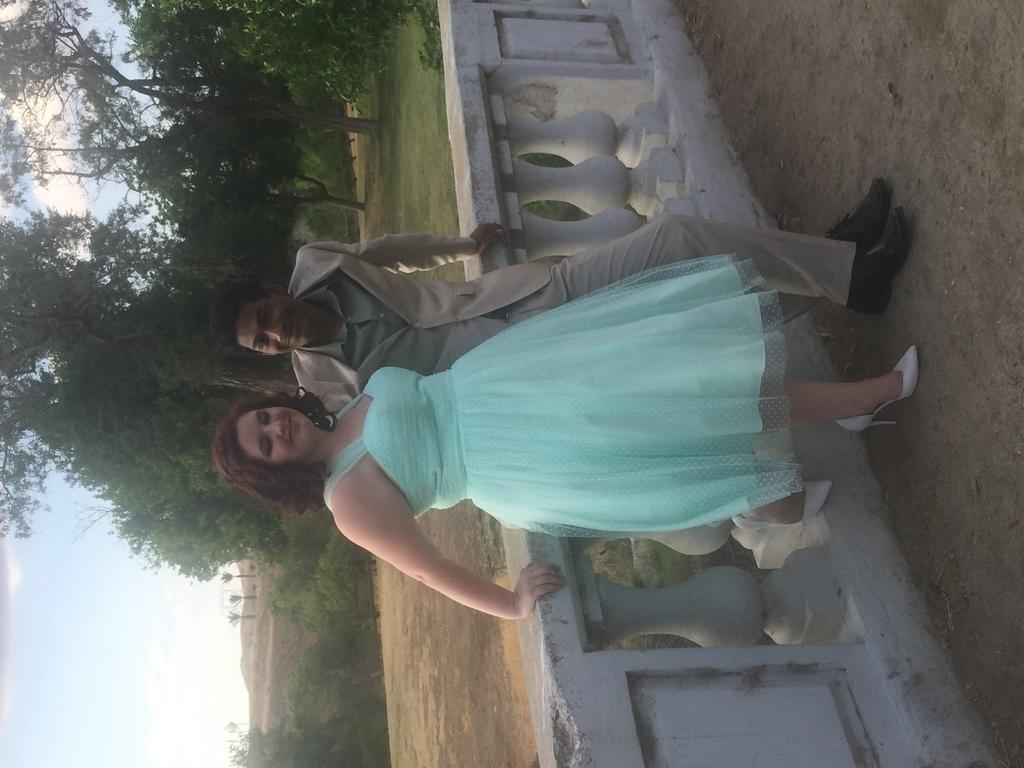How many people are present in the image? There are two people in the image. What is the primary surface visible in the image? There is a ground visible in the image. What type of vegetation can be seen on the ground in the image? There are trees on the ground in the image. What type of chair can be seen in the downtown competition in the image? There is no chair, downtown, or competition present in the image. 